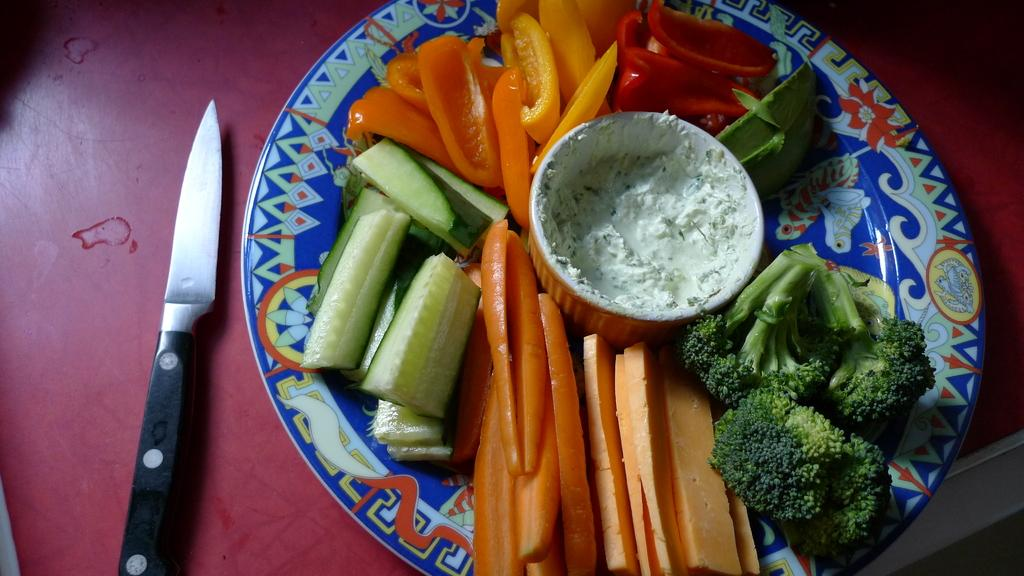What is on the plate in the image? There is a plate with cutting vegetables in the image. What other dish is present in the image? There is a bowl in the image. Where is the knife located in the image? The knife is on the left side of the image. What type of spring can be seen in the image? There is no spring present in the image; it features a plate with cutting vegetables, a bowl, and a knife. What kind of trouble is the person in the image experiencing? There is no person present in the image, so it is not possible to determine if they are experiencing any trouble. 